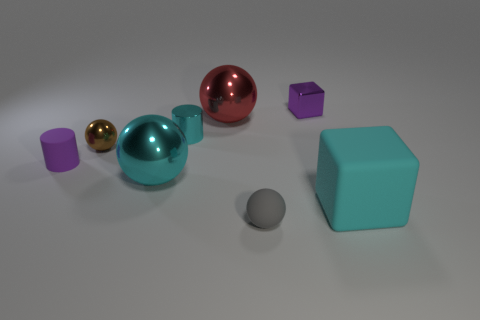The tiny metallic cylinder has what color?
Your response must be concise. Cyan. What material is the other tiny object that is the same shape as the purple matte object?
Your response must be concise. Metal. Is there any other thing that has the same material as the small block?
Offer a terse response. Yes. Does the tiny shiny sphere have the same color as the big block?
Provide a succinct answer. No. What is the shape of the cyan thing right of the block behind the large rubber block?
Ensure brevity in your answer.  Cube. What is the shape of the purple thing that is the same material as the big block?
Offer a terse response. Cylinder. How many other things are the same shape as the cyan matte thing?
Provide a succinct answer. 1. Is the size of the matte object that is left of the gray thing the same as the cyan metallic cylinder?
Offer a terse response. Yes. Are there more large blocks on the right side of the brown object than big spheres?
Your answer should be very brief. No. How many tiny gray spheres are in front of the small purple object that is on the left side of the tiny purple shiny object?
Provide a succinct answer. 1. 